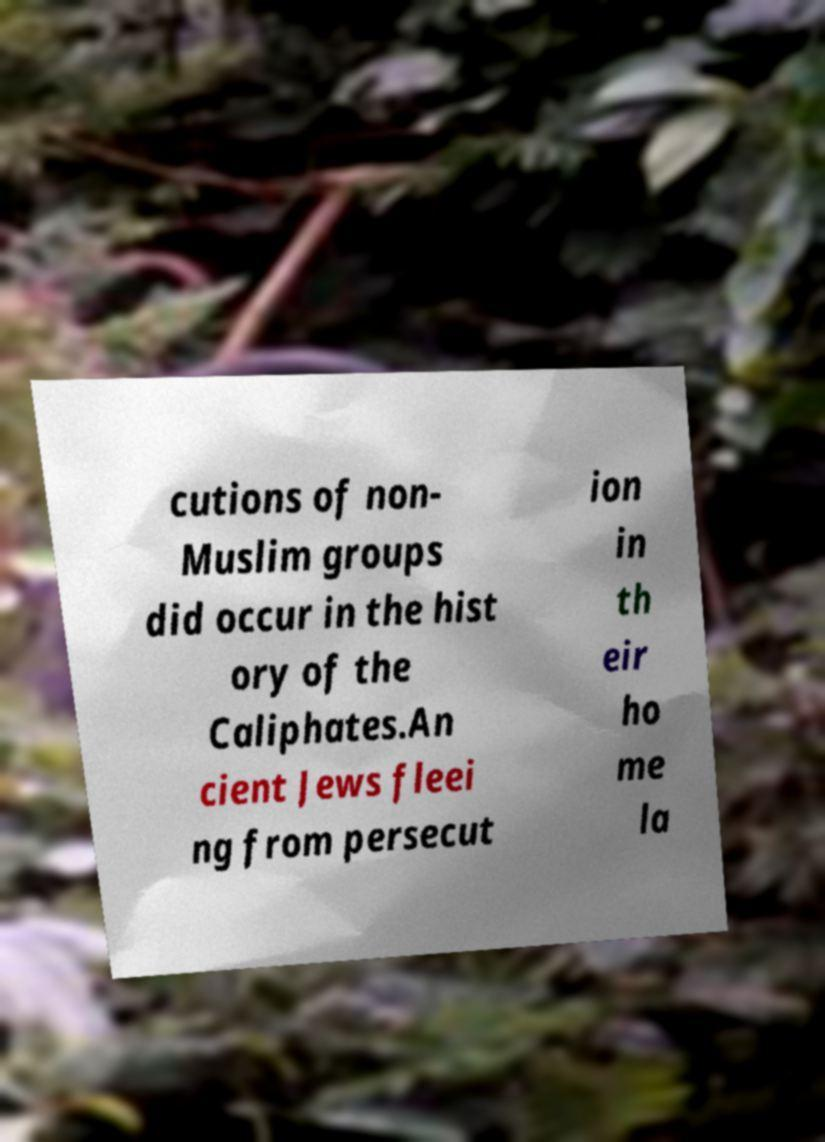Please identify and transcribe the text found in this image. cutions of non- Muslim groups did occur in the hist ory of the Caliphates.An cient Jews fleei ng from persecut ion in th eir ho me la 